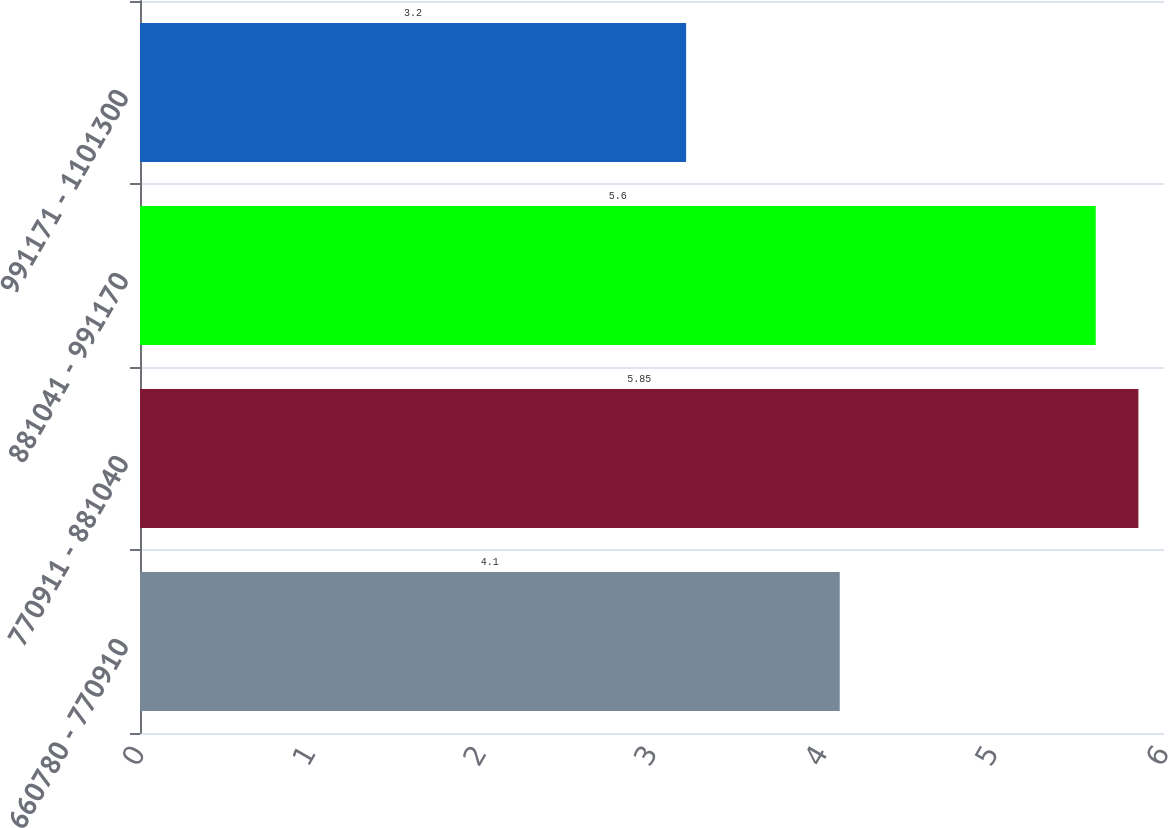Convert chart to OTSL. <chart><loc_0><loc_0><loc_500><loc_500><bar_chart><fcel>660780 - 770910<fcel>770911 - 881040<fcel>881041 - 991170<fcel>991171 - 1101300<nl><fcel>4.1<fcel>5.85<fcel>5.6<fcel>3.2<nl></chart> 